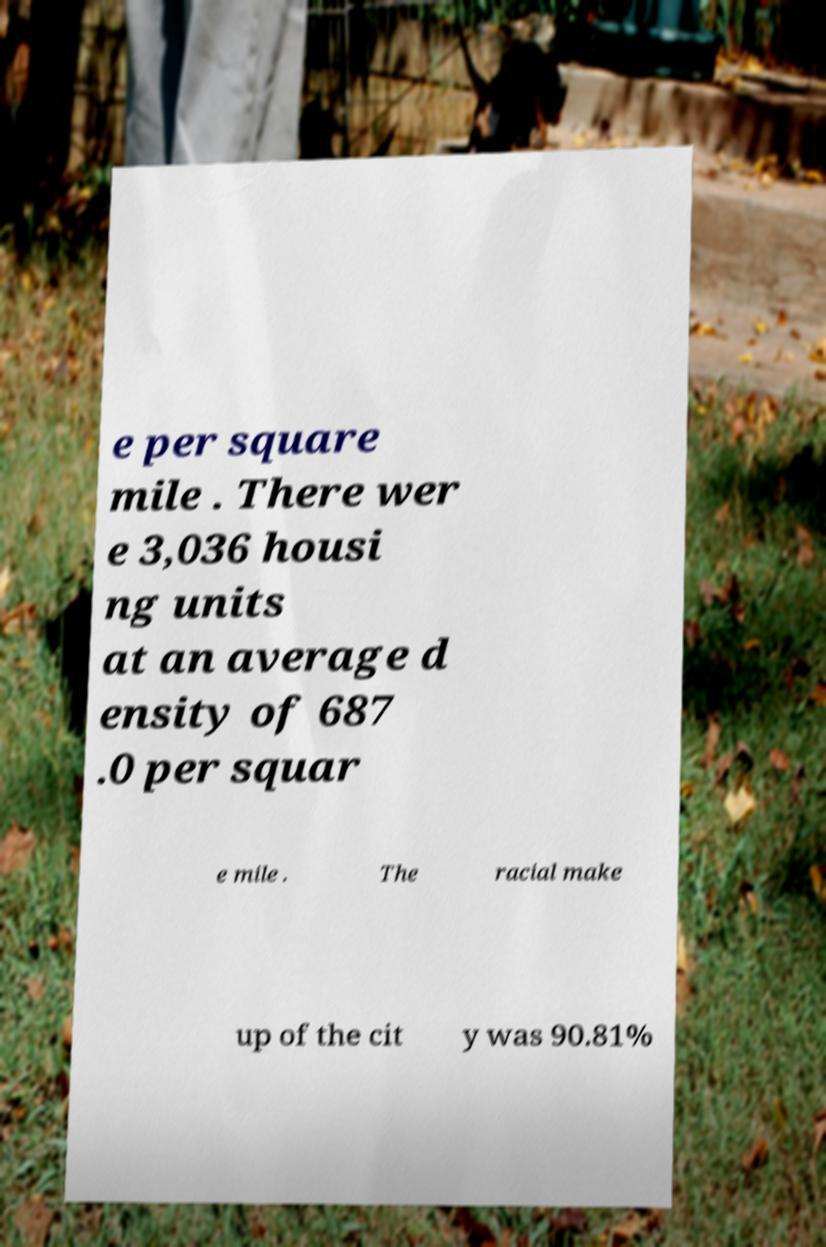Could you extract and type out the text from this image? e per square mile . There wer e 3,036 housi ng units at an average d ensity of 687 .0 per squar e mile . The racial make up of the cit y was 90.81% 